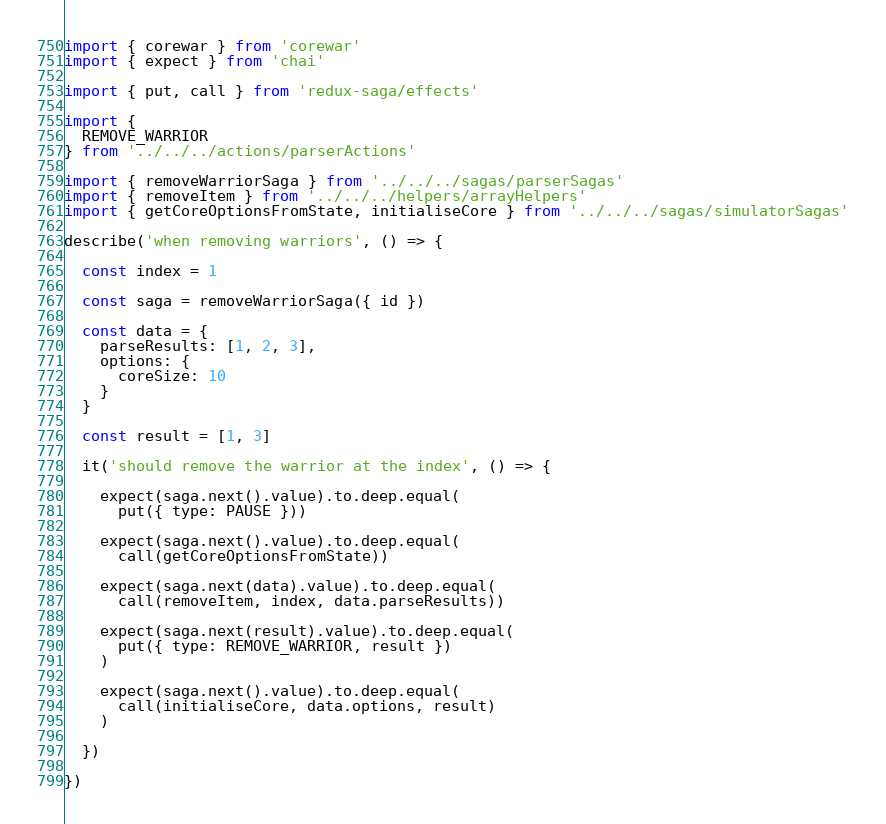<code> <loc_0><loc_0><loc_500><loc_500><_JavaScript_>

import { corewar } from 'corewar'
import { expect } from 'chai'

import { put, call } from 'redux-saga/effects'

import {
  REMOVE_WARRIOR
} from '../../../actions/parserActions'

import { removeWarriorSaga } from '../../../sagas/parserSagas'
import { removeItem } from '../../../helpers/arrayHelpers'
import { getCoreOptionsFromState, initialiseCore } from '../../../sagas/simulatorSagas'

describe('when removing warriors', () => {

  const index = 1

  const saga = removeWarriorSaga({ id })

  const data = {
    parseResults: [1, 2, 3],
    options: {
      coreSize: 10
    }
  }

  const result = [1, 3]

  it('should remove the warrior at the index', () => {

    expect(saga.next().value).to.deep.equal(
      put({ type: PAUSE }))

    expect(saga.next().value).to.deep.equal(
      call(getCoreOptionsFromState))

    expect(saga.next(data).value).to.deep.equal(
      call(removeItem, index, data.parseResults))

    expect(saga.next(result).value).to.deep.equal(
      put({ type: REMOVE_WARRIOR, result })
    )

    expect(saga.next().value).to.deep.equal(
      call(initialiseCore, data.options, result)
    )

  })

})</code> 